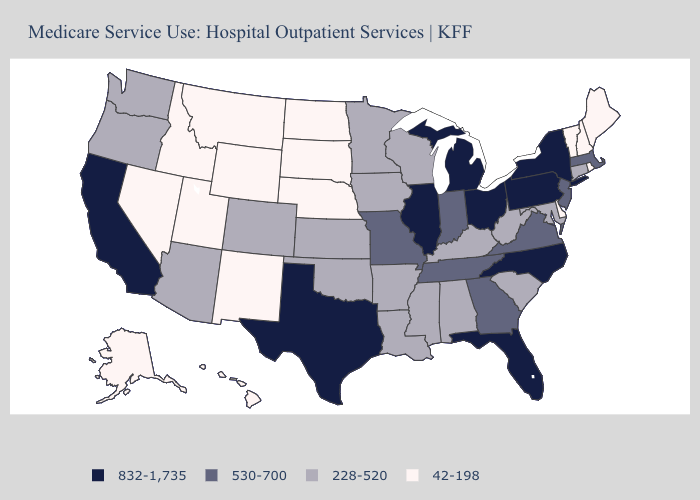Among the states that border Tennessee , which have the lowest value?
Short answer required. Alabama, Arkansas, Kentucky, Mississippi. What is the lowest value in states that border Louisiana?
Keep it brief. 228-520. Does the map have missing data?
Give a very brief answer. No. Name the states that have a value in the range 832-1,735?
Answer briefly. California, Florida, Illinois, Michigan, New York, North Carolina, Ohio, Pennsylvania, Texas. Is the legend a continuous bar?
Be succinct. No. What is the value of Hawaii?
Write a very short answer. 42-198. What is the value of Montana?
Concise answer only. 42-198. What is the lowest value in the South?
Give a very brief answer. 42-198. Name the states that have a value in the range 42-198?
Write a very short answer. Alaska, Delaware, Hawaii, Idaho, Maine, Montana, Nebraska, Nevada, New Hampshire, New Mexico, North Dakota, Rhode Island, South Dakota, Utah, Vermont, Wyoming. Among the states that border Tennessee , does Missouri have the highest value?
Concise answer only. No. Among the states that border Connecticut , does Massachusetts have the lowest value?
Short answer required. No. Which states have the highest value in the USA?
Be succinct. California, Florida, Illinois, Michigan, New York, North Carolina, Ohio, Pennsylvania, Texas. What is the value of Nebraska?
Short answer required. 42-198. Does Massachusetts have the lowest value in the Northeast?
Write a very short answer. No. What is the highest value in the Northeast ?
Write a very short answer. 832-1,735. 